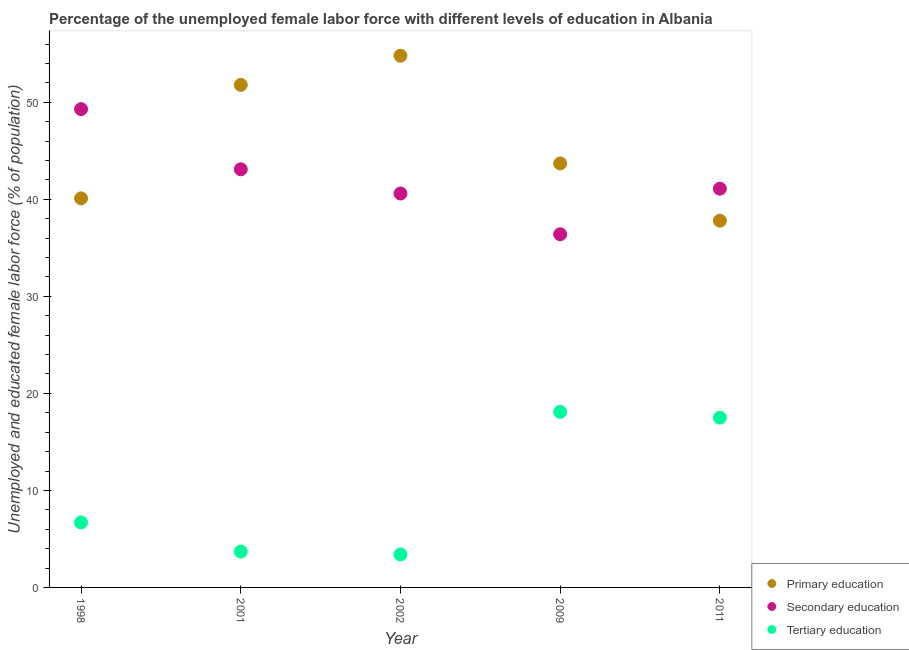How many different coloured dotlines are there?
Keep it short and to the point. 3. What is the percentage of female labor force who received secondary education in 2011?
Give a very brief answer. 41.1. Across all years, what is the maximum percentage of female labor force who received secondary education?
Your answer should be compact. 49.3. Across all years, what is the minimum percentage of female labor force who received secondary education?
Keep it short and to the point. 36.4. In which year was the percentage of female labor force who received secondary education minimum?
Provide a succinct answer. 2009. What is the total percentage of female labor force who received primary education in the graph?
Provide a short and direct response. 228.2. What is the difference between the percentage of female labor force who received secondary education in 2001 and that in 2009?
Your answer should be very brief. 6.7. What is the average percentage of female labor force who received secondary education per year?
Your response must be concise. 42.1. In the year 2002, what is the difference between the percentage of female labor force who received tertiary education and percentage of female labor force who received secondary education?
Your answer should be compact. -37.2. What is the ratio of the percentage of female labor force who received primary education in 2001 to that in 2009?
Your answer should be very brief. 1.19. What is the difference between the highest and the second highest percentage of female labor force who received tertiary education?
Provide a short and direct response. 0.6. What is the difference between the highest and the lowest percentage of female labor force who received tertiary education?
Offer a terse response. 14.7. Is it the case that in every year, the sum of the percentage of female labor force who received primary education and percentage of female labor force who received secondary education is greater than the percentage of female labor force who received tertiary education?
Provide a succinct answer. Yes. How many dotlines are there?
Make the answer very short. 3. Are the values on the major ticks of Y-axis written in scientific E-notation?
Give a very brief answer. No. Does the graph contain grids?
Ensure brevity in your answer.  No. What is the title of the graph?
Your answer should be compact. Percentage of the unemployed female labor force with different levels of education in Albania. What is the label or title of the X-axis?
Provide a succinct answer. Year. What is the label or title of the Y-axis?
Offer a terse response. Unemployed and educated female labor force (% of population). What is the Unemployed and educated female labor force (% of population) in Primary education in 1998?
Make the answer very short. 40.1. What is the Unemployed and educated female labor force (% of population) in Secondary education in 1998?
Your response must be concise. 49.3. What is the Unemployed and educated female labor force (% of population) in Tertiary education in 1998?
Offer a terse response. 6.7. What is the Unemployed and educated female labor force (% of population) of Primary education in 2001?
Provide a succinct answer. 51.8. What is the Unemployed and educated female labor force (% of population) of Secondary education in 2001?
Make the answer very short. 43.1. What is the Unemployed and educated female labor force (% of population) of Tertiary education in 2001?
Your answer should be compact. 3.7. What is the Unemployed and educated female labor force (% of population) in Primary education in 2002?
Make the answer very short. 54.8. What is the Unemployed and educated female labor force (% of population) of Secondary education in 2002?
Offer a terse response. 40.6. What is the Unemployed and educated female labor force (% of population) of Tertiary education in 2002?
Your answer should be very brief. 3.4. What is the Unemployed and educated female labor force (% of population) in Primary education in 2009?
Offer a very short reply. 43.7. What is the Unemployed and educated female labor force (% of population) in Secondary education in 2009?
Ensure brevity in your answer.  36.4. What is the Unemployed and educated female labor force (% of population) of Tertiary education in 2009?
Ensure brevity in your answer.  18.1. What is the Unemployed and educated female labor force (% of population) of Primary education in 2011?
Your answer should be compact. 37.8. What is the Unemployed and educated female labor force (% of population) in Secondary education in 2011?
Provide a short and direct response. 41.1. What is the Unemployed and educated female labor force (% of population) in Tertiary education in 2011?
Provide a short and direct response. 17.5. Across all years, what is the maximum Unemployed and educated female labor force (% of population) of Primary education?
Offer a terse response. 54.8. Across all years, what is the maximum Unemployed and educated female labor force (% of population) of Secondary education?
Offer a terse response. 49.3. Across all years, what is the maximum Unemployed and educated female labor force (% of population) of Tertiary education?
Offer a very short reply. 18.1. Across all years, what is the minimum Unemployed and educated female labor force (% of population) of Primary education?
Keep it short and to the point. 37.8. Across all years, what is the minimum Unemployed and educated female labor force (% of population) of Secondary education?
Make the answer very short. 36.4. Across all years, what is the minimum Unemployed and educated female labor force (% of population) of Tertiary education?
Offer a terse response. 3.4. What is the total Unemployed and educated female labor force (% of population) in Primary education in the graph?
Provide a succinct answer. 228.2. What is the total Unemployed and educated female labor force (% of population) in Secondary education in the graph?
Provide a succinct answer. 210.5. What is the total Unemployed and educated female labor force (% of population) of Tertiary education in the graph?
Ensure brevity in your answer.  49.4. What is the difference between the Unemployed and educated female labor force (% of population) in Secondary education in 1998 and that in 2001?
Offer a terse response. 6.2. What is the difference between the Unemployed and educated female labor force (% of population) of Primary education in 1998 and that in 2002?
Provide a short and direct response. -14.7. What is the difference between the Unemployed and educated female labor force (% of population) of Tertiary education in 1998 and that in 2002?
Offer a very short reply. 3.3. What is the difference between the Unemployed and educated female labor force (% of population) of Primary education in 1998 and that in 2009?
Ensure brevity in your answer.  -3.6. What is the difference between the Unemployed and educated female labor force (% of population) of Tertiary education in 1998 and that in 2009?
Make the answer very short. -11.4. What is the difference between the Unemployed and educated female labor force (% of population) of Primary education in 1998 and that in 2011?
Make the answer very short. 2.3. What is the difference between the Unemployed and educated female labor force (% of population) in Secondary education in 2001 and that in 2002?
Make the answer very short. 2.5. What is the difference between the Unemployed and educated female labor force (% of population) in Tertiary education in 2001 and that in 2002?
Your answer should be very brief. 0.3. What is the difference between the Unemployed and educated female labor force (% of population) of Primary education in 2001 and that in 2009?
Ensure brevity in your answer.  8.1. What is the difference between the Unemployed and educated female labor force (% of population) in Secondary education in 2001 and that in 2009?
Your response must be concise. 6.7. What is the difference between the Unemployed and educated female labor force (% of population) of Tertiary education in 2001 and that in 2009?
Offer a very short reply. -14.4. What is the difference between the Unemployed and educated female labor force (% of population) of Tertiary education in 2001 and that in 2011?
Your response must be concise. -13.8. What is the difference between the Unemployed and educated female labor force (% of population) in Secondary education in 2002 and that in 2009?
Keep it short and to the point. 4.2. What is the difference between the Unemployed and educated female labor force (% of population) in Tertiary education in 2002 and that in 2009?
Your answer should be compact. -14.7. What is the difference between the Unemployed and educated female labor force (% of population) of Primary education in 2002 and that in 2011?
Make the answer very short. 17. What is the difference between the Unemployed and educated female labor force (% of population) of Secondary education in 2002 and that in 2011?
Make the answer very short. -0.5. What is the difference between the Unemployed and educated female labor force (% of population) in Tertiary education in 2002 and that in 2011?
Provide a short and direct response. -14.1. What is the difference between the Unemployed and educated female labor force (% of population) of Primary education in 2009 and that in 2011?
Make the answer very short. 5.9. What is the difference between the Unemployed and educated female labor force (% of population) of Tertiary education in 2009 and that in 2011?
Provide a short and direct response. 0.6. What is the difference between the Unemployed and educated female labor force (% of population) of Primary education in 1998 and the Unemployed and educated female labor force (% of population) of Secondary education in 2001?
Offer a terse response. -3. What is the difference between the Unemployed and educated female labor force (% of population) of Primary education in 1998 and the Unemployed and educated female labor force (% of population) of Tertiary education in 2001?
Keep it short and to the point. 36.4. What is the difference between the Unemployed and educated female labor force (% of population) in Secondary education in 1998 and the Unemployed and educated female labor force (% of population) in Tertiary education in 2001?
Provide a short and direct response. 45.6. What is the difference between the Unemployed and educated female labor force (% of population) in Primary education in 1998 and the Unemployed and educated female labor force (% of population) in Tertiary education in 2002?
Keep it short and to the point. 36.7. What is the difference between the Unemployed and educated female labor force (% of population) of Secondary education in 1998 and the Unemployed and educated female labor force (% of population) of Tertiary education in 2002?
Keep it short and to the point. 45.9. What is the difference between the Unemployed and educated female labor force (% of population) in Primary education in 1998 and the Unemployed and educated female labor force (% of population) in Secondary education in 2009?
Your response must be concise. 3.7. What is the difference between the Unemployed and educated female labor force (% of population) of Primary education in 1998 and the Unemployed and educated female labor force (% of population) of Tertiary education in 2009?
Offer a very short reply. 22. What is the difference between the Unemployed and educated female labor force (% of population) of Secondary education in 1998 and the Unemployed and educated female labor force (% of population) of Tertiary education in 2009?
Provide a short and direct response. 31.2. What is the difference between the Unemployed and educated female labor force (% of population) of Primary education in 1998 and the Unemployed and educated female labor force (% of population) of Tertiary education in 2011?
Give a very brief answer. 22.6. What is the difference between the Unemployed and educated female labor force (% of population) in Secondary education in 1998 and the Unemployed and educated female labor force (% of population) in Tertiary education in 2011?
Your answer should be compact. 31.8. What is the difference between the Unemployed and educated female labor force (% of population) of Primary education in 2001 and the Unemployed and educated female labor force (% of population) of Secondary education in 2002?
Provide a succinct answer. 11.2. What is the difference between the Unemployed and educated female labor force (% of population) in Primary education in 2001 and the Unemployed and educated female labor force (% of population) in Tertiary education in 2002?
Give a very brief answer. 48.4. What is the difference between the Unemployed and educated female labor force (% of population) of Secondary education in 2001 and the Unemployed and educated female labor force (% of population) of Tertiary education in 2002?
Your answer should be compact. 39.7. What is the difference between the Unemployed and educated female labor force (% of population) of Primary education in 2001 and the Unemployed and educated female labor force (% of population) of Tertiary education in 2009?
Offer a very short reply. 33.7. What is the difference between the Unemployed and educated female labor force (% of population) in Primary education in 2001 and the Unemployed and educated female labor force (% of population) in Secondary education in 2011?
Provide a succinct answer. 10.7. What is the difference between the Unemployed and educated female labor force (% of population) in Primary education in 2001 and the Unemployed and educated female labor force (% of population) in Tertiary education in 2011?
Your answer should be very brief. 34.3. What is the difference between the Unemployed and educated female labor force (% of population) of Secondary education in 2001 and the Unemployed and educated female labor force (% of population) of Tertiary education in 2011?
Give a very brief answer. 25.6. What is the difference between the Unemployed and educated female labor force (% of population) in Primary education in 2002 and the Unemployed and educated female labor force (% of population) in Tertiary education in 2009?
Your response must be concise. 36.7. What is the difference between the Unemployed and educated female labor force (% of population) in Primary education in 2002 and the Unemployed and educated female labor force (% of population) in Secondary education in 2011?
Your response must be concise. 13.7. What is the difference between the Unemployed and educated female labor force (% of population) of Primary education in 2002 and the Unemployed and educated female labor force (% of population) of Tertiary education in 2011?
Your response must be concise. 37.3. What is the difference between the Unemployed and educated female labor force (% of population) of Secondary education in 2002 and the Unemployed and educated female labor force (% of population) of Tertiary education in 2011?
Ensure brevity in your answer.  23.1. What is the difference between the Unemployed and educated female labor force (% of population) in Primary education in 2009 and the Unemployed and educated female labor force (% of population) in Secondary education in 2011?
Keep it short and to the point. 2.6. What is the difference between the Unemployed and educated female labor force (% of population) of Primary education in 2009 and the Unemployed and educated female labor force (% of population) of Tertiary education in 2011?
Your answer should be very brief. 26.2. What is the difference between the Unemployed and educated female labor force (% of population) of Secondary education in 2009 and the Unemployed and educated female labor force (% of population) of Tertiary education in 2011?
Offer a very short reply. 18.9. What is the average Unemployed and educated female labor force (% of population) in Primary education per year?
Provide a succinct answer. 45.64. What is the average Unemployed and educated female labor force (% of population) in Secondary education per year?
Provide a short and direct response. 42.1. What is the average Unemployed and educated female labor force (% of population) of Tertiary education per year?
Give a very brief answer. 9.88. In the year 1998, what is the difference between the Unemployed and educated female labor force (% of population) in Primary education and Unemployed and educated female labor force (% of population) in Secondary education?
Your response must be concise. -9.2. In the year 1998, what is the difference between the Unemployed and educated female labor force (% of population) of Primary education and Unemployed and educated female labor force (% of population) of Tertiary education?
Offer a very short reply. 33.4. In the year 1998, what is the difference between the Unemployed and educated female labor force (% of population) of Secondary education and Unemployed and educated female labor force (% of population) of Tertiary education?
Make the answer very short. 42.6. In the year 2001, what is the difference between the Unemployed and educated female labor force (% of population) in Primary education and Unemployed and educated female labor force (% of population) in Secondary education?
Your response must be concise. 8.7. In the year 2001, what is the difference between the Unemployed and educated female labor force (% of population) of Primary education and Unemployed and educated female labor force (% of population) of Tertiary education?
Offer a terse response. 48.1. In the year 2001, what is the difference between the Unemployed and educated female labor force (% of population) in Secondary education and Unemployed and educated female labor force (% of population) in Tertiary education?
Keep it short and to the point. 39.4. In the year 2002, what is the difference between the Unemployed and educated female labor force (% of population) of Primary education and Unemployed and educated female labor force (% of population) of Secondary education?
Your answer should be very brief. 14.2. In the year 2002, what is the difference between the Unemployed and educated female labor force (% of population) of Primary education and Unemployed and educated female labor force (% of population) of Tertiary education?
Your answer should be very brief. 51.4. In the year 2002, what is the difference between the Unemployed and educated female labor force (% of population) in Secondary education and Unemployed and educated female labor force (% of population) in Tertiary education?
Provide a short and direct response. 37.2. In the year 2009, what is the difference between the Unemployed and educated female labor force (% of population) of Primary education and Unemployed and educated female labor force (% of population) of Secondary education?
Your answer should be compact. 7.3. In the year 2009, what is the difference between the Unemployed and educated female labor force (% of population) of Primary education and Unemployed and educated female labor force (% of population) of Tertiary education?
Your answer should be very brief. 25.6. In the year 2011, what is the difference between the Unemployed and educated female labor force (% of population) of Primary education and Unemployed and educated female labor force (% of population) of Secondary education?
Your response must be concise. -3.3. In the year 2011, what is the difference between the Unemployed and educated female labor force (% of population) in Primary education and Unemployed and educated female labor force (% of population) in Tertiary education?
Ensure brevity in your answer.  20.3. In the year 2011, what is the difference between the Unemployed and educated female labor force (% of population) of Secondary education and Unemployed and educated female labor force (% of population) of Tertiary education?
Give a very brief answer. 23.6. What is the ratio of the Unemployed and educated female labor force (% of population) in Primary education in 1998 to that in 2001?
Offer a terse response. 0.77. What is the ratio of the Unemployed and educated female labor force (% of population) of Secondary education in 1998 to that in 2001?
Make the answer very short. 1.14. What is the ratio of the Unemployed and educated female labor force (% of population) of Tertiary education in 1998 to that in 2001?
Make the answer very short. 1.81. What is the ratio of the Unemployed and educated female labor force (% of population) in Primary education in 1998 to that in 2002?
Your response must be concise. 0.73. What is the ratio of the Unemployed and educated female labor force (% of population) of Secondary education in 1998 to that in 2002?
Your response must be concise. 1.21. What is the ratio of the Unemployed and educated female labor force (% of population) in Tertiary education in 1998 to that in 2002?
Keep it short and to the point. 1.97. What is the ratio of the Unemployed and educated female labor force (% of population) of Primary education in 1998 to that in 2009?
Provide a short and direct response. 0.92. What is the ratio of the Unemployed and educated female labor force (% of population) in Secondary education in 1998 to that in 2009?
Ensure brevity in your answer.  1.35. What is the ratio of the Unemployed and educated female labor force (% of population) of Tertiary education in 1998 to that in 2009?
Keep it short and to the point. 0.37. What is the ratio of the Unemployed and educated female labor force (% of population) of Primary education in 1998 to that in 2011?
Keep it short and to the point. 1.06. What is the ratio of the Unemployed and educated female labor force (% of population) of Secondary education in 1998 to that in 2011?
Offer a very short reply. 1.2. What is the ratio of the Unemployed and educated female labor force (% of population) in Tertiary education in 1998 to that in 2011?
Ensure brevity in your answer.  0.38. What is the ratio of the Unemployed and educated female labor force (% of population) in Primary education in 2001 to that in 2002?
Give a very brief answer. 0.95. What is the ratio of the Unemployed and educated female labor force (% of population) of Secondary education in 2001 to that in 2002?
Provide a short and direct response. 1.06. What is the ratio of the Unemployed and educated female labor force (% of population) of Tertiary education in 2001 to that in 2002?
Offer a very short reply. 1.09. What is the ratio of the Unemployed and educated female labor force (% of population) of Primary education in 2001 to that in 2009?
Your answer should be compact. 1.19. What is the ratio of the Unemployed and educated female labor force (% of population) of Secondary education in 2001 to that in 2009?
Give a very brief answer. 1.18. What is the ratio of the Unemployed and educated female labor force (% of population) in Tertiary education in 2001 to that in 2009?
Your response must be concise. 0.2. What is the ratio of the Unemployed and educated female labor force (% of population) of Primary education in 2001 to that in 2011?
Your response must be concise. 1.37. What is the ratio of the Unemployed and educated female labor force (% of population) of Secondary education in 2001 to that in 2011?
Your answer should be very brief. 1.05. What is the ratio of the Unemployed and educated female labor force (% of population) of Tertiary education in 2001 to that in 2011?
Provide a short and direct response. 0.21. What is the ratio of the Unemployed and educated female labor force (% of population) in Primary education in 2002 to that in 2009?
Ensure brevity in your answer.  1.25. What is the ratio of the Unemployed and educated female labor force (% of population) in Secondary education in 2002 to that in 2009?
Provide a short and direct response. 1.12. What is the ratio of the Unemployed and educated female labor force (% of population) of Tertiary education in 2002 to that in 2009?
Your response must be concise. 0.19. What is the ratio of the Unemployed and educated female labor force (% of population) of Primary education in 2002 to that in 2011?
Offer a terse response. 1.45. What is the ratio of the Unemployed and educated female labor force (% of population) in Secondary education in 2002 to that in 2011?
Provide a succinct answer. 0.99. What is the ratio of the Unemployed and educated female labor force (% of population) in Tertiary education in 2002 to that in 2011?
Provide a short and direct response. 0.19. What is the ratio of the Unemployed and educated female labor force (% of population) in Primary education in 2009 to that in 2011?
Your answer should be compact. 1.16. What is the ratio of the Unemployed and educated female labor force (% of population) of Secondary education in 2009 to that in 2011?
Your answer should be very brief. 0.89. What is the ratio of the Unemployed and educated female labor force (% of population) in Tertiary education in 2009 to that in 2011?
Provide a short and direct response. 1.03. What is the difference between the highest and the second highest Unemployed and educated female labor force (% of population) in Tertiary education?
Provide a succinct answer. 0.6. What is the difference between the highest and the lowest Unemployed and educated female labor force (% of population) in Secondary education?
Offer a terse response. 12.9. 